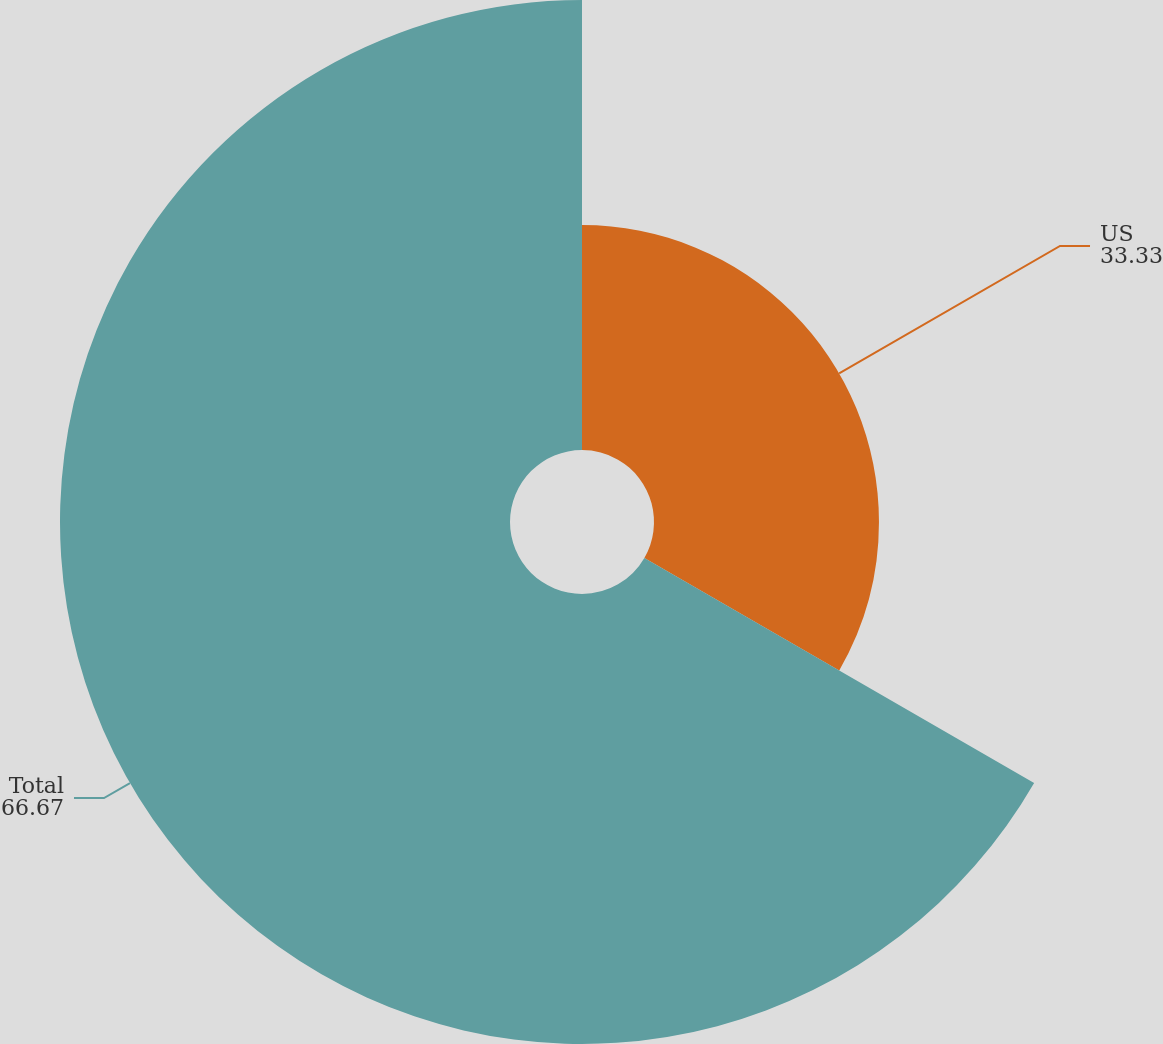Convert chart to OTSL. <chart><loc_0><loc_0><loc_500><loc_500><pie_chart><fcel>US<fcel>Total<nl><fcel>33.33%<fcel>66.67%<nl></chart> 